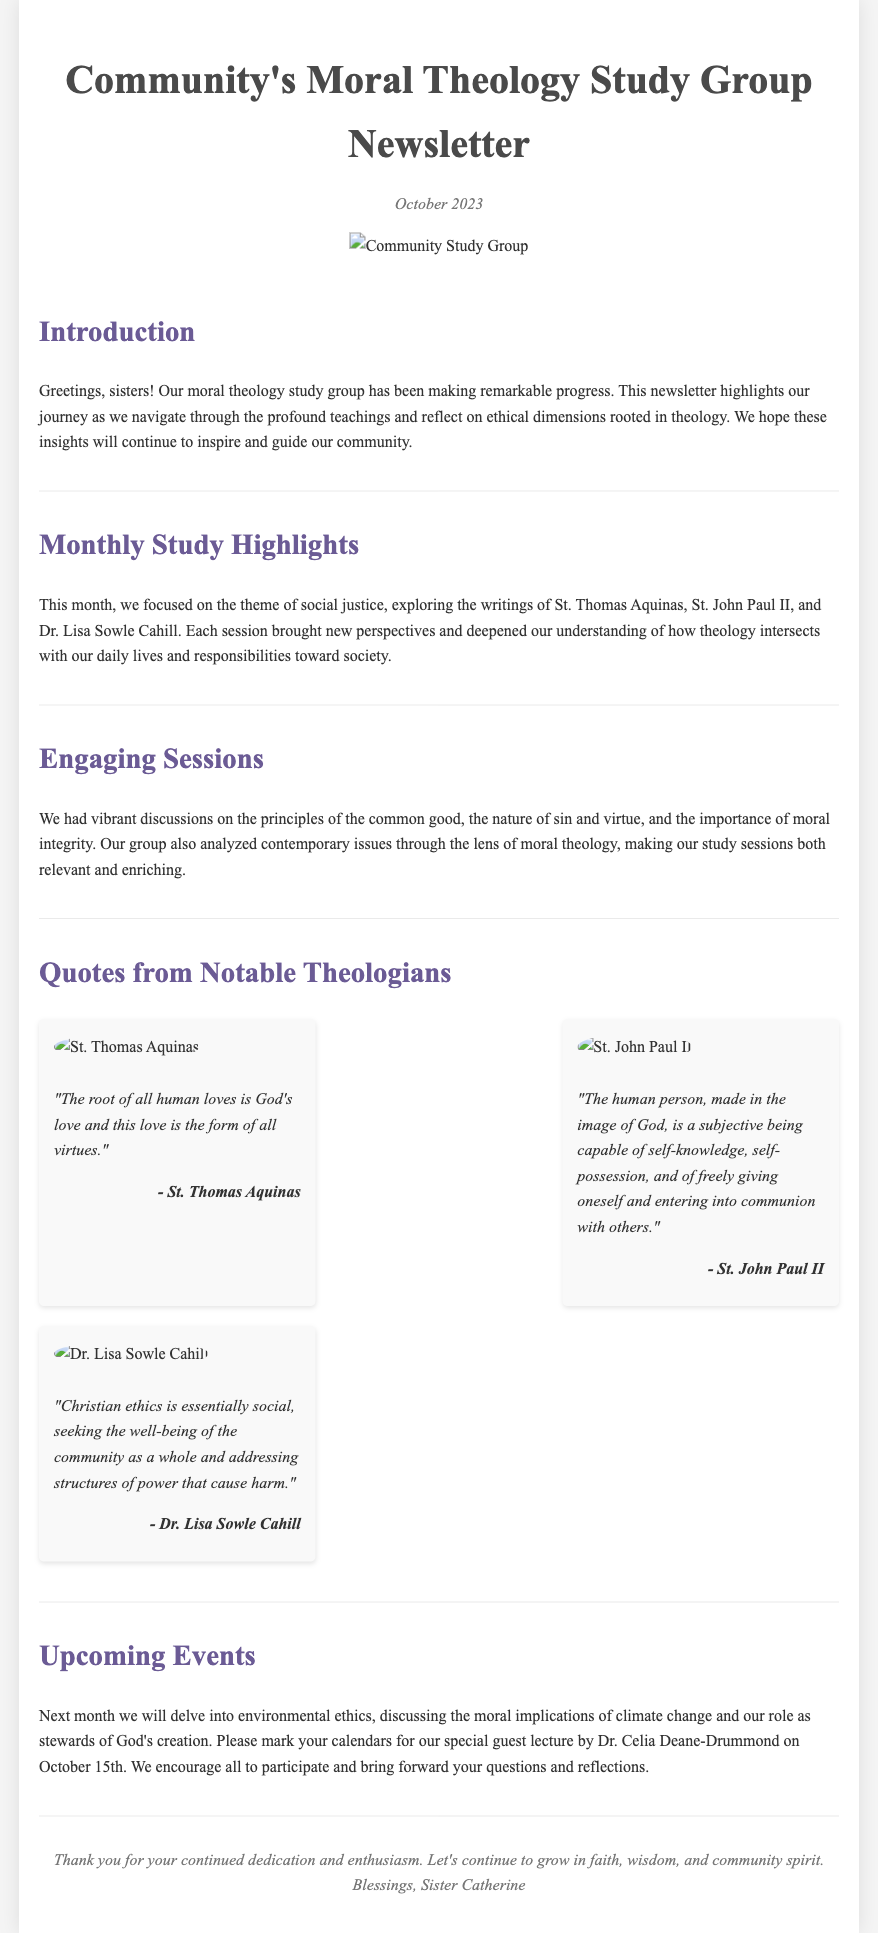What is the title of the newsletter? The title of the newsletter is prominently displayed in the header of the document.
Answer: Community's Moral Theology Study Group Newsletter When was the newsletter published? The publication date is mentioned right after the title in the header section.
Answer: October 2023 Who is the author of the closing remarks? The author of the closing remarks is indicated in the footer of the document.
Answer: Sister Catherine What is the theme of the monthly study for this newsletter? The monthly study theme is detailed in the section discussing the study highlights.
Answer: social justice What notable theologian will speak at the upcoming event? The upcoming event mentions a special guest lecture with a specific theologian.
Answer: Dr. Celia Deane-Drummond Which theologian's quote emphasizes God's love as the root of all human loves? The quote in the quotes section relates to the root of human loves.
Answer: St. Thomas Aquinas How many notable theologians' quotes are presented in the document? The number of quotes can be counted in the quotes section of the newsletter.
Answer: Three What moral issue will be discussed in next month's meeting? The content regarding the next month's focus is outlined in the upcoming events section.
Answer: environmental ethics What principle did the group analyze related to contemporary issues? The principle is mentioned in the section discussing engaging sessions.
Answer: moral integrity 